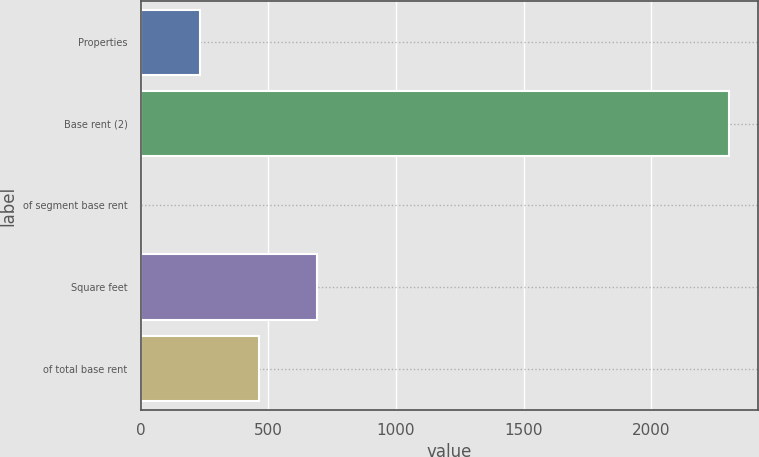Convert chart to OTSL. <chart><loc_0><loc_0><loc_500><loc_500><bar_chart><fcel>Properties<fcel>Base rent (2)<fcel>of segment base rent<fcel>Square feet<fcel>of total base rent<nl><fcel>231.4<fcel>2305<fcel>1<fcel>692.2<fcel>461.8<nl></chart> 